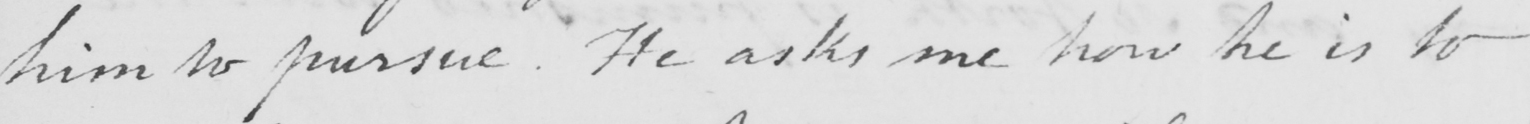What text is written in this handwritten line? him to pursue . He asks me how he is to 